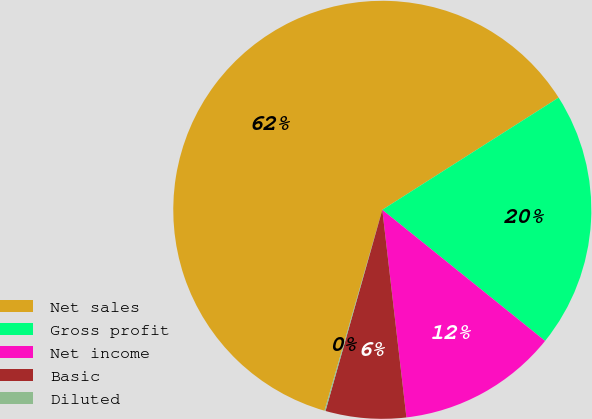Convert chart to OTSL. <chart><loc_0><loc_0><loc_500><loc_500><pie_chart><fcel>Net sales<fcel>Gross profit<fcel>Net income<fcel>Basic<fcel>Diluted<nl><fcel>61.53%<fcel>19.81%<fcel>12.37%<fcel>6.22%<fcel>0.08%<nl></chart> 